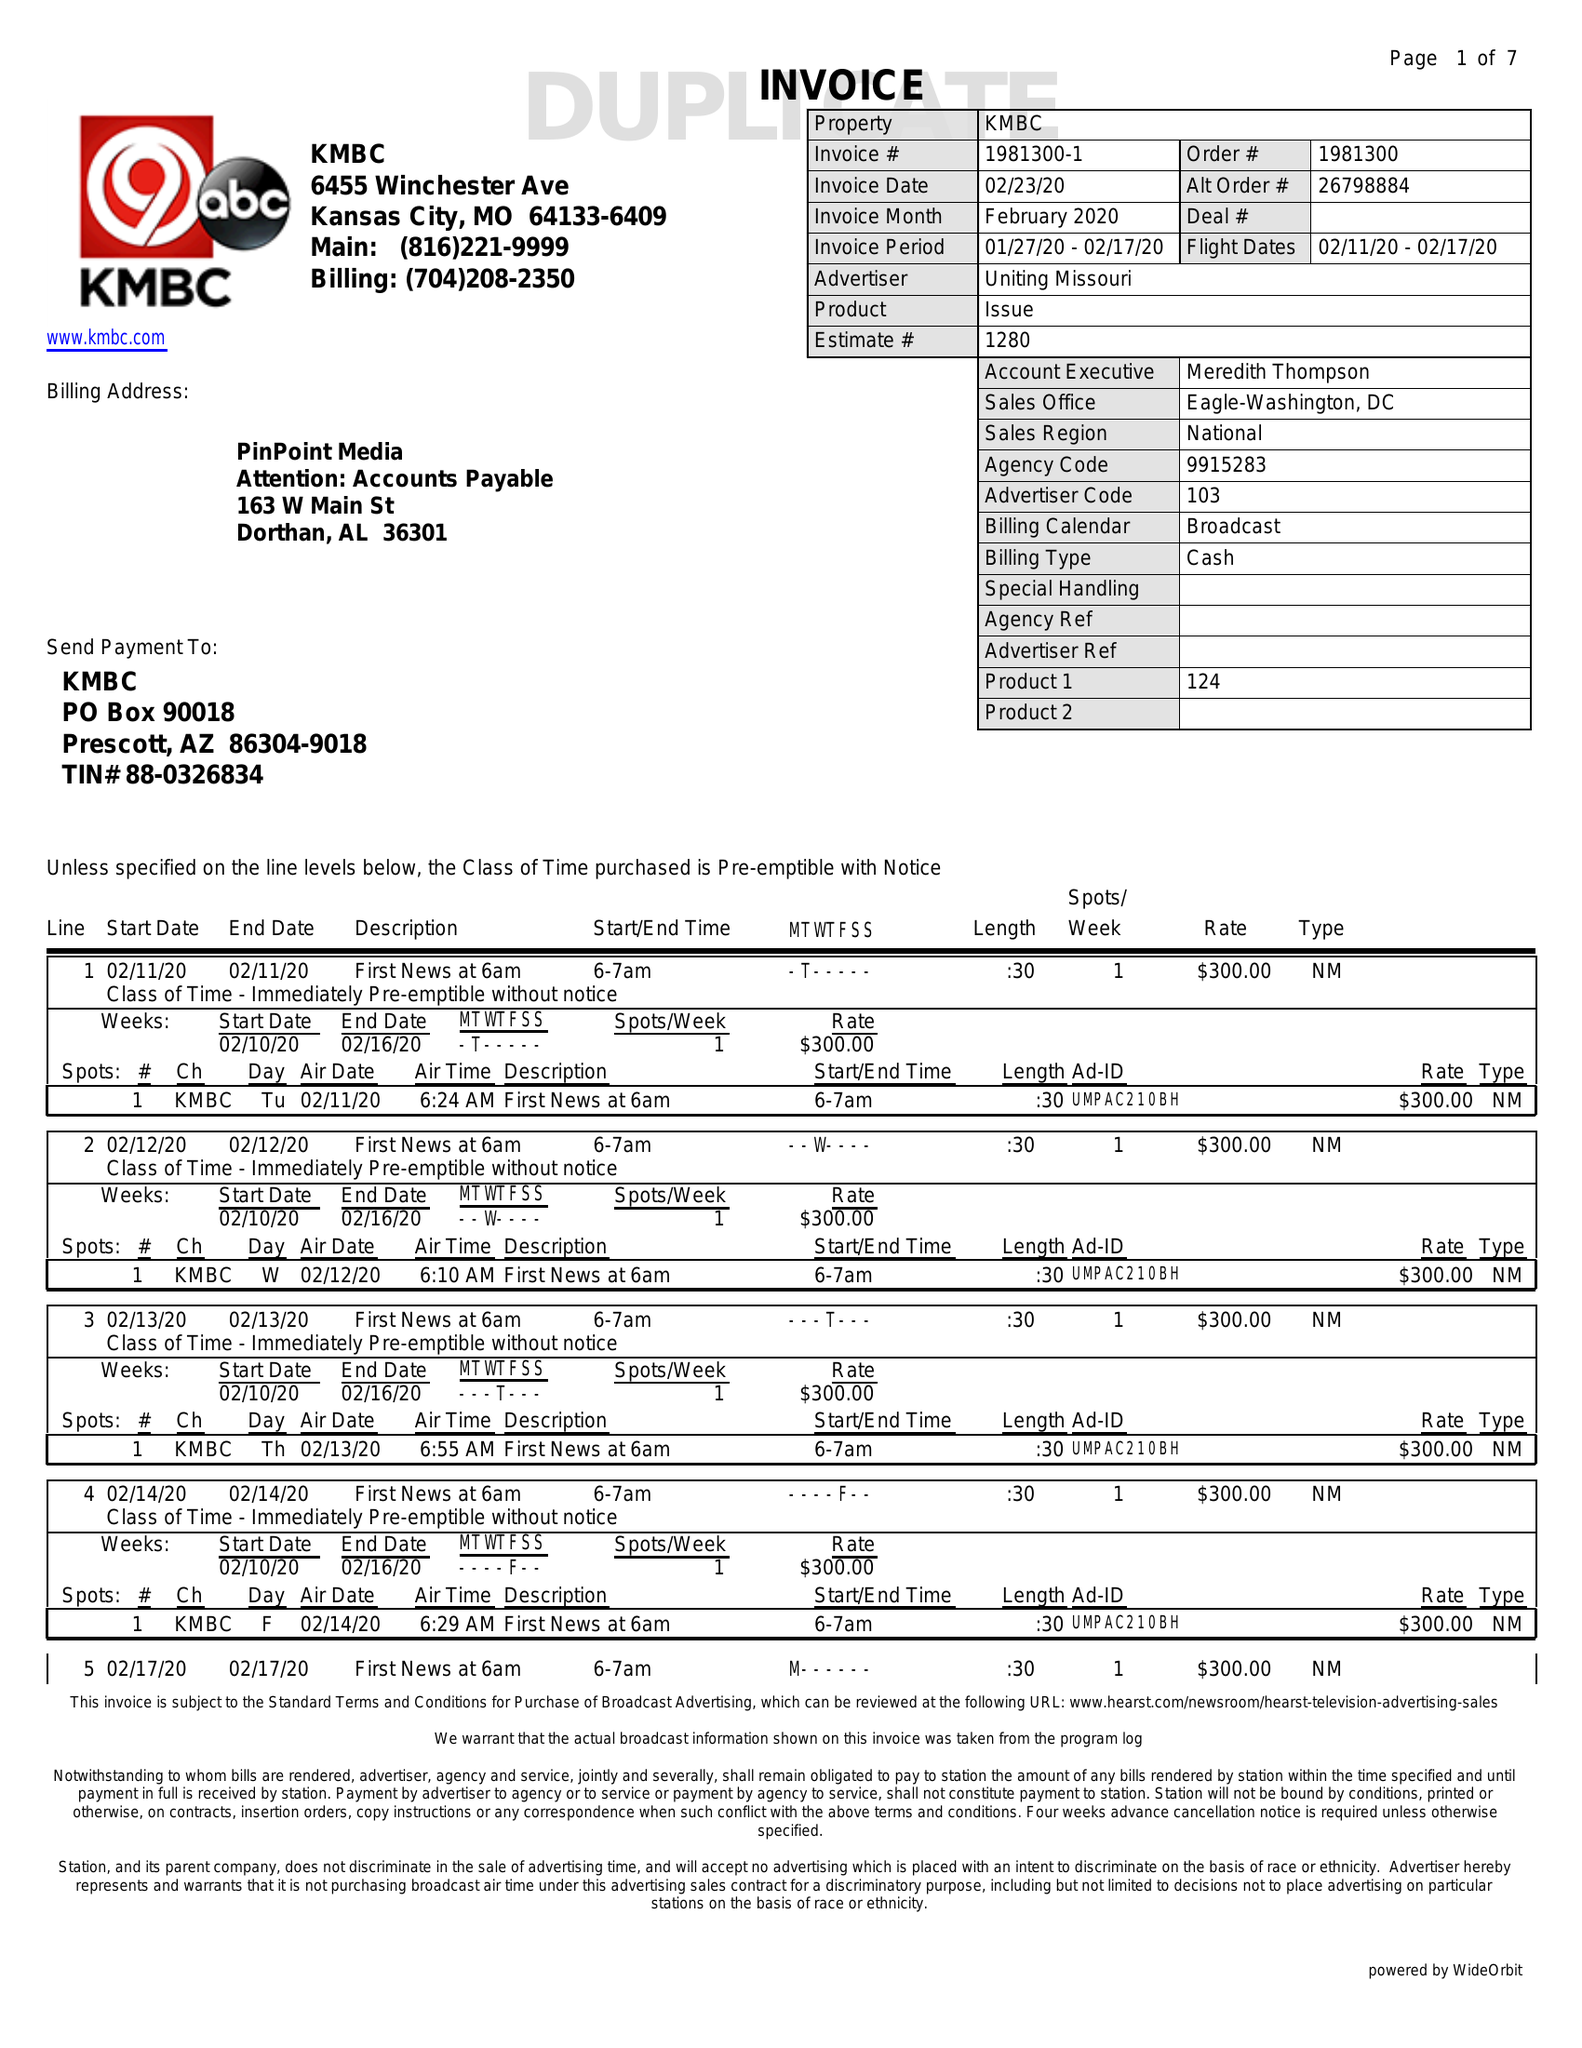What is the value for the gross_amount?
Answer the question using a single word or phrase. 16675.00 